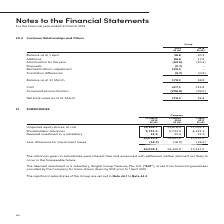According to Singapore Telecommunications's financial document, What is the topic of note 21? According to the financial document, Subsidiaries. The relevant text states: "21. SUBSIDIARIES..." Also, Which subsidiary is there a deemed investment in? Based on the financial document, the answer is Singtel Group Treasury Pte. Ltd. (“SGT”). Also, What are the terms of the shareholders' advances? interest-free and unsecured with settlement neither planned nor likely to occur in the foreseeable future. The document states: "The advances given to subsidiaries were interest-free and unsecured with settlement neither planned nor likely to occur in the foreseeable future...." Also, can you calculate: What is the average balance of the total across the 3 years? To answer this question, I need to perform calculations using the financial data. The calculation is: (20,009.2 + 19,425.9 + 17,441.0) / 3, which equals 18958.7 (in millions). This is based on the information: "owance for impairment losses (16.0) (16.0) (16.0) 20,009.2 19,425.9 17,441.0 ent losses (16.0) (16.0) (16.0) 20,009.2 19,425.9 17,441.0 r impairment losses (16.0) (16.0) (16.0) 20,009.2 19,425.9 17,44..." The key data points involved are: 17,441.0, 19,425.9, 20,009.2. Also, can you calculate: What is the average allowance for impairment losses across the 3 years? To answer this question, I need to perform calculations using the financial data. The calculation is: (16.0 + 16.0 + 16.0 )/ 3, which equals 16 (in millions). This is based on the information: "17,457.0 Less : Allowance for impairment losses (16.0) (16.0) (16.0) 20,009.2 19,425.9 17,441.0..." Also, How many factors are involved in calculating the balance for subsidiaries? Counting the relevant items in the document: Unquoted equity shares, Shareholders' advances, Deemed investment in a subsidiary, Allowance for impairment losses, I find 4 instances. The key data points involved are: Allowance for impairment losses, Deemed investment in a subsidiary, Shareholders' advances. 